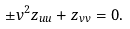Convert formula to latex. <formula><loc_0><loc_0><loc_500><loc_500>\pm v ^ { 2 } z _ { u u } + z _ { v v } = 0 .</formula> 